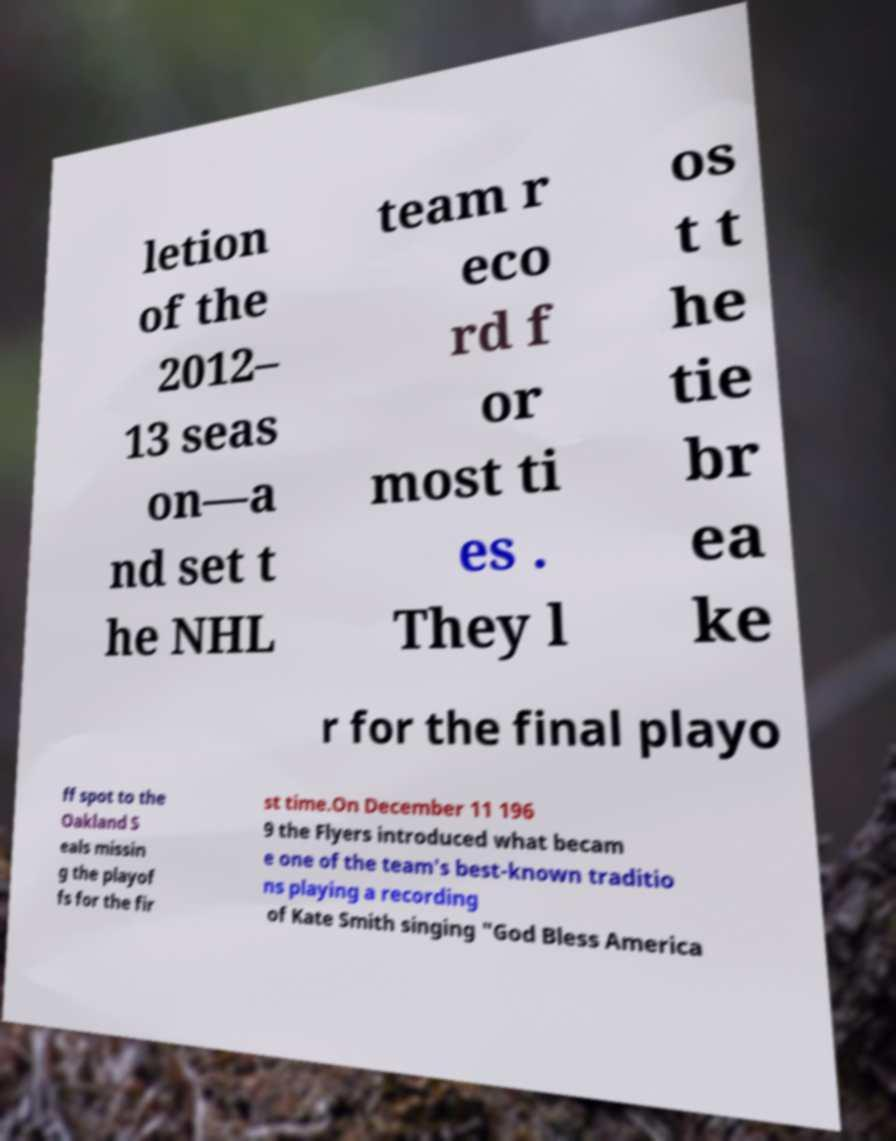Can you accurately transcribe the text from the provided image for me? letion of the 2012– 13 seas on—a nd set t he NHL team r eco rd f or most ti es . They l os t t he tie br ea ke r for the final playo ff spot to the Oakland S eals missin g the playof fs for the fir st time.On December 11 196 9 the Flyers introduced what becam e one of the team's best-known traditio ns playing a recording of Kate Smith singing "God Bless America 